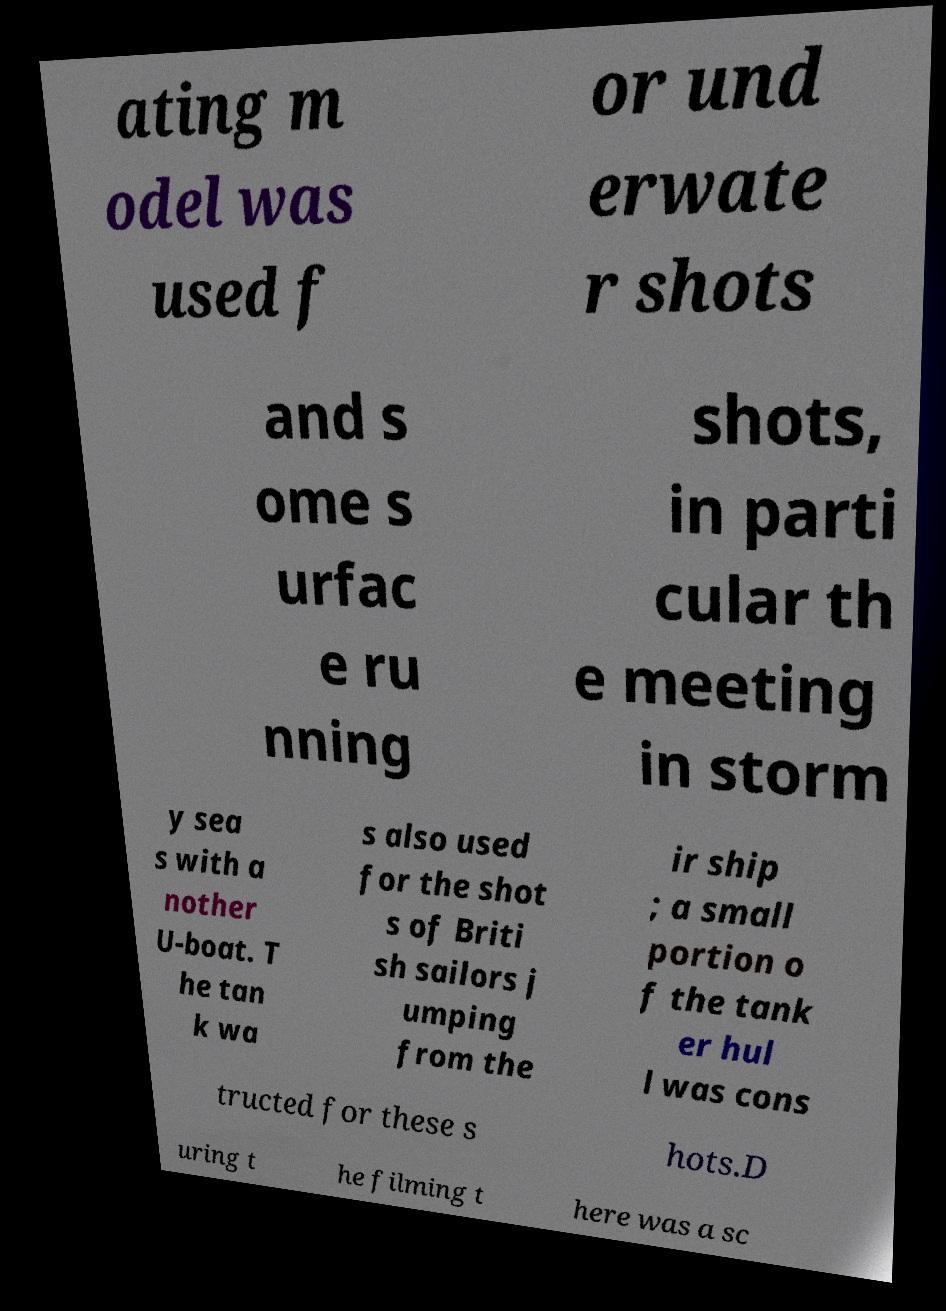Could you extract and type out the text from this image? ating m odel was used f or und erwate r shots and s ome s urfac e ru nning shots, in parti cular th e meeting in storm y sea s with a nother U-boat. T he tan k wa s also used for the shot s of Briti sh sailors j umping from the ir ship ; a small portion o f the tank er hul l was cons tructed for these s hots.D uring t he filming t here was a sc 